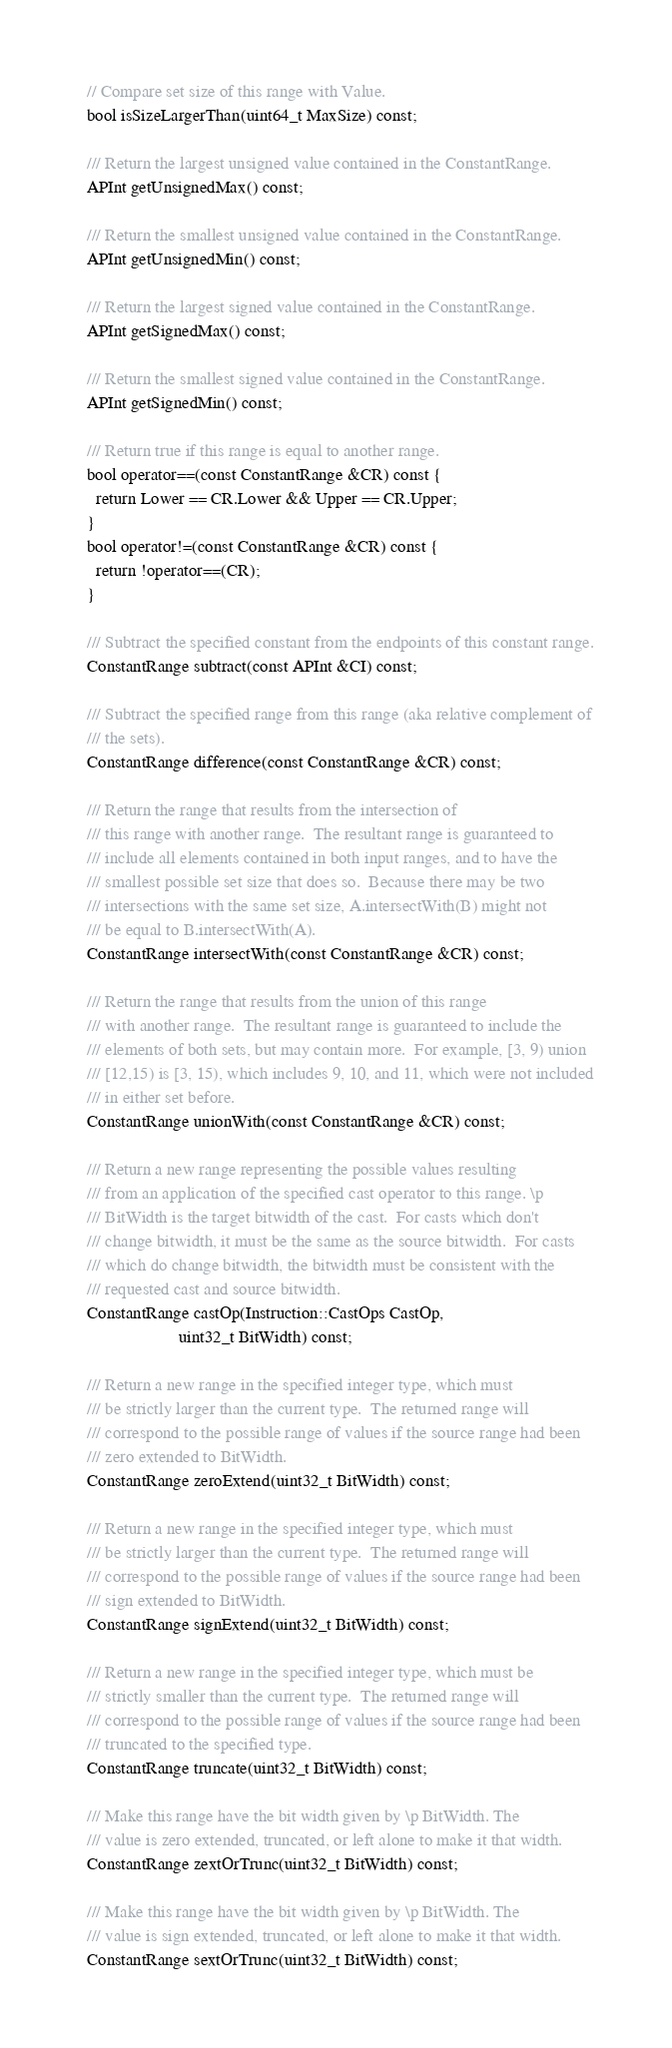Convert code to text. <code><loc_0><loc_0><loc_500><loc_500><_C_>
  // Compare set size of this range with Value.
  bool isSizeLargerThan(uint64_t MaxSize) const;

  /// Return the largest unsigned value contained in the ConstantRange.
  APInt getUnsignedMax() const;

  /// Return the smallest unsigned value contained in the ConstantRange.
  APInt getUnsignedMin() const;

  /// Return the largest signed value contained in the ConstantRange.
  APInt getSignedMax() const;

  /// Return the smallest signed value contained in the ConstantRange.
  APInt getSignedMin() const;

  /// Return true if this range is equal to another range.
  bool operator==(const ConstantRange &CR) const {
    return Lower == CR.Lower && Upper == CR.Upper;
  }
  bool operator!=(const ConstantRange &CR) const {
    return !operator==(CR);
  }

  /// Subtract the specified constant from the endpoints of this constant range.
  ConstantRange subtract(const APInt &CI) const;

  /// Subtract the specified range from this range (aka relative complement of
  /// the sets).
  ConstantRange difference(const ConstantRange &CR) const;

  /// Return the range that results from the intersection of
  /// this range with another range.  The resultant range is guaranteed to
  /// include all elements contained in both input ranges, and to have the
  /// smallest possible set size that does so.  Because there may be two
  /// intersections with the same set size, A.intersectWith(B) might not
  /// be equal to B.intersectWith(A).
  ConstantRange intersectWith(const ConstantRange &CR) const;

  /// Return the range that results from the union of this range
  /// with another range.  The resultant range is guaranteed to include the
  /// elements of both sets, but may contain more.  For example, [3, 9) union
  /// [12,15) is [3, 15), which includes 9, 10, and 11, which were not included
  /// in either set before.
  ConstantRange unionWith(const ConstantRange &CR) const;

  /// Return a new range representing the possible values resulting
  /// from an application of the specified cast operator to this range. \p
  /// BitWidth is the target bitwidth of the cast.  For casts which don't
  /// change bitwidth, it must be the same as the source bitwidth.  For casts
  /// which do change bitwidth, the bitwidth must be consistent with the
  /// requested cast and source bitwidth.
  ConstantRange castOp(Instruction::CastOps CastOp,
                       uint32_t BitWidth) const;

  /// Return a new range in the specified integer type, which must
  /// be strictly larger than the current type.  The returned range will
  /// correspond to the possible range of values if the source range had been
  /// zero extended to BitWidth.
  ConstantRange zeroExtend(uint32_t BitWidth) const;

  /// Return a new range in the specified integer type, which must
  /// be strictly larger than the current type.  The returned range will
  /// correspond to the possible range of values if the source range had been
  /// sign extended to BitWidth.
  ConstantRange signExtend(uint32_t BitWidth) const;

  /// Return a new range in the specified integer type, which must be
  /// strictly smaller than the current type.  The returned range will
  /// correspond to the possible range of values if the source range had been
  /// truncated to the specified type.
  ConstantRange truncate(uint32_t BitWidth) const;

  /// Make this range have the bit width given by \p BitWidth. The
  /// value is zero extended, truncated, or left alone to make it that width.
  ConstantRange zextOrTrunc(uint32_t BitWidth) const;

  /// Make this range have the bit width given by \p BitWidth. The
  /// value is sign extended, truncated, or left alone to make it that width.
  ConstantRange sextOrTrunc(uint32_t BitWidth) const;
</code> 